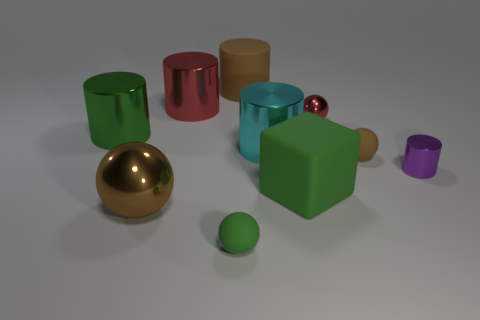What is the texture on the gold sphere like compared to the matte surfaces of the other objects? The gold sphere in the image has a highly reflective, smooth surface that suggests a metallic texture. This is in contrast to the matte surfaces of the other objects, which have a more subdued appearance, likely due to being made of a non-metallic material or having a coating that scatters light, rather than reflecting it directly. Could the matte objects be used in a setting where lower reflection is needed? Absolutely, the matte objects in the image would be ideal in settings where low reflectivity is desired, such as in the filmmaking or photography industries where controlling light reflection is essential, or in a workspace with abundant natural light to reduce glare. 